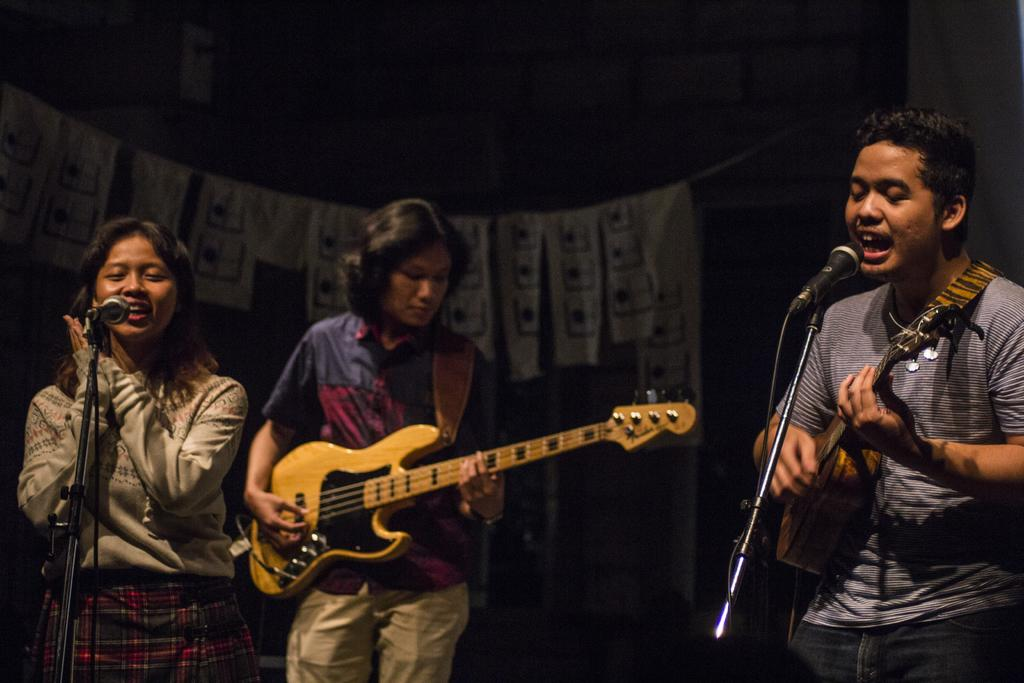How many people are in the image? There are three persons in the image. What are the persons doing in the image? The persons are playing musical instruments and singing together. What type of lumber is being used to create the melody in the image? There is no lumber present in the image; the persons are playing musical instruments, not using lumber to create music. 